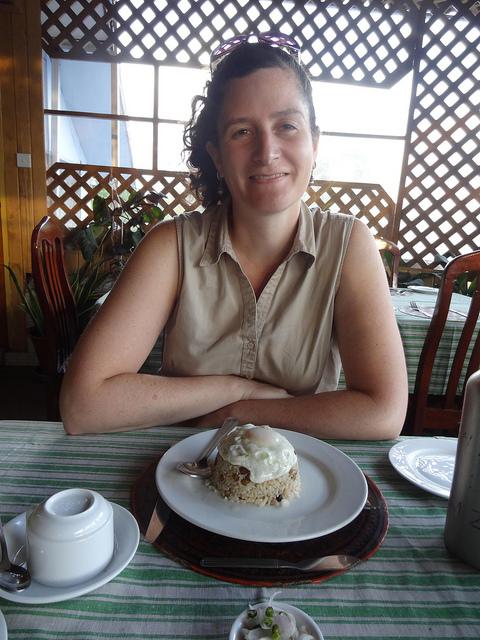What kind of plant is in the background?
Keep it brief. Houseplant. What is the lady eating?
Quick response, please. Egg. Is her cup full?
Quick response, please. No. 